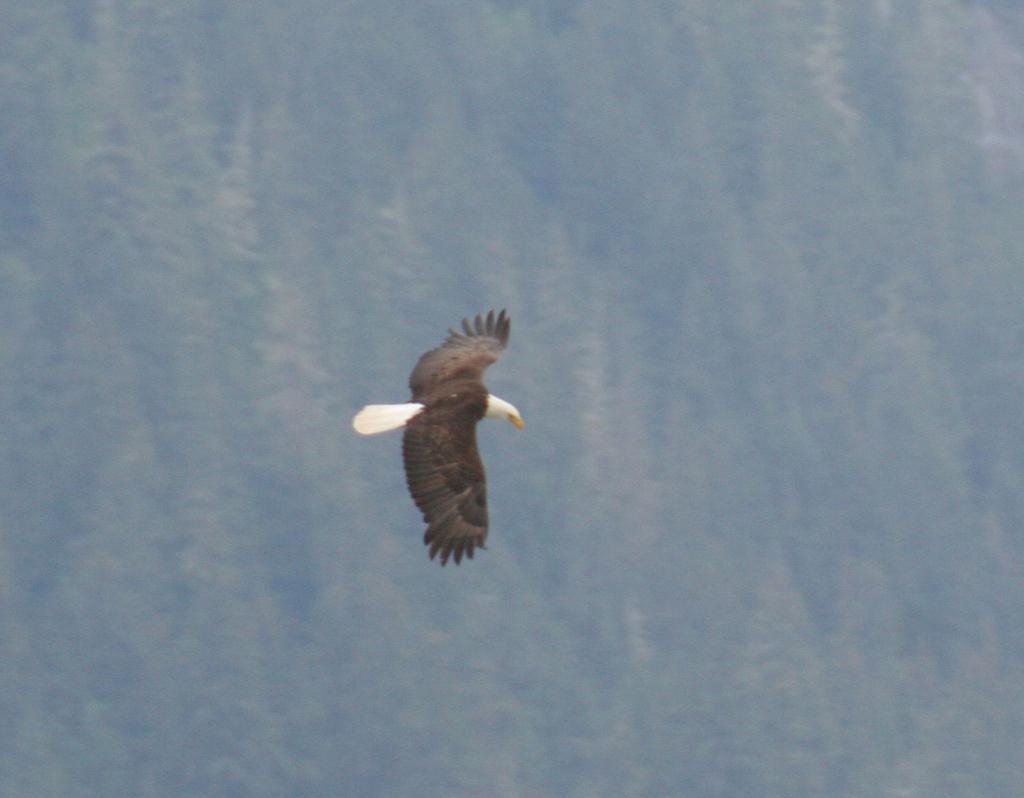Describe this image in one or two sentences. In this image there is a bird flying in the air and there is a blurred background. 